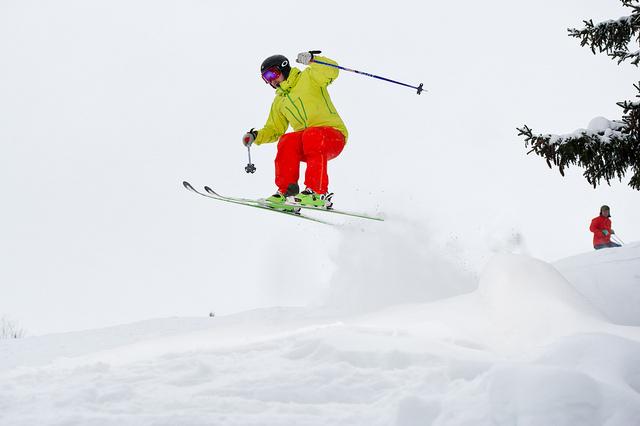What pattern is on the shirt?
Answer briefly. Solid. Is the skier on the snow?
Concise answer only. No. Is the person wearing sunglasses?
Keep it brief. Yes. What color are his pants?
Concise answer only. Red. 